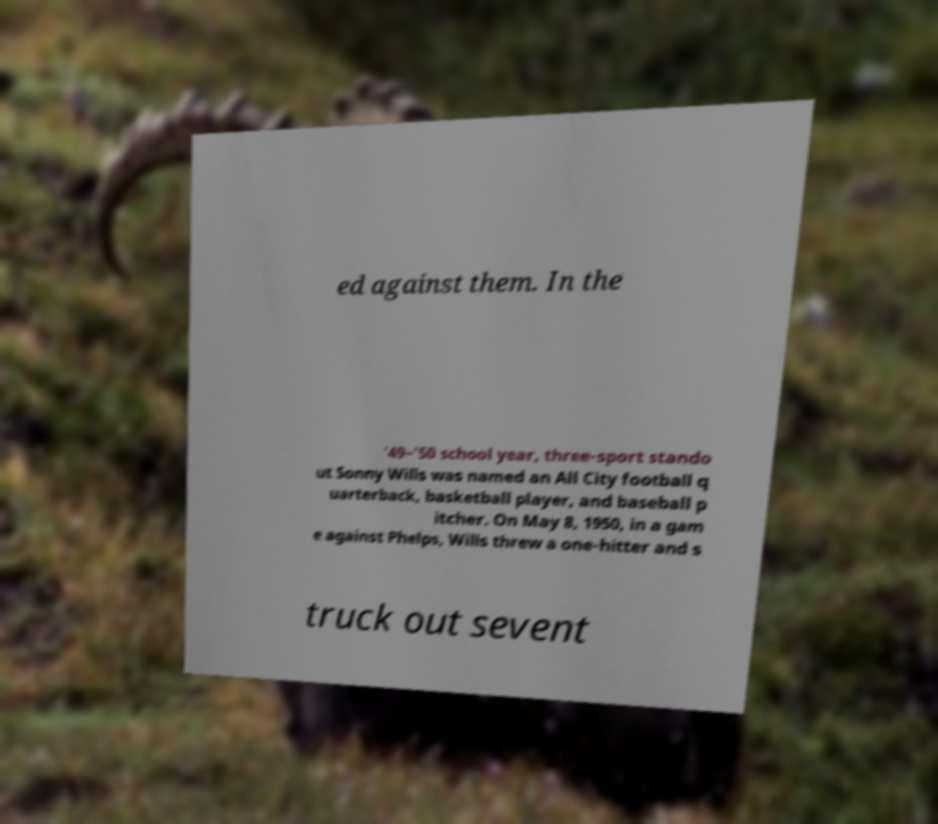I need the written content from this picture converted into text. Can you do that? ed against them. In the '49–'50 school year, three-sport stando ut Sonny Wills was named an All City football q uarterback, basketball player, and baseball p itcher. On May 8, 1950, in a gam e against Phelps, Wills threw a one-hitter and s truck out sevent 